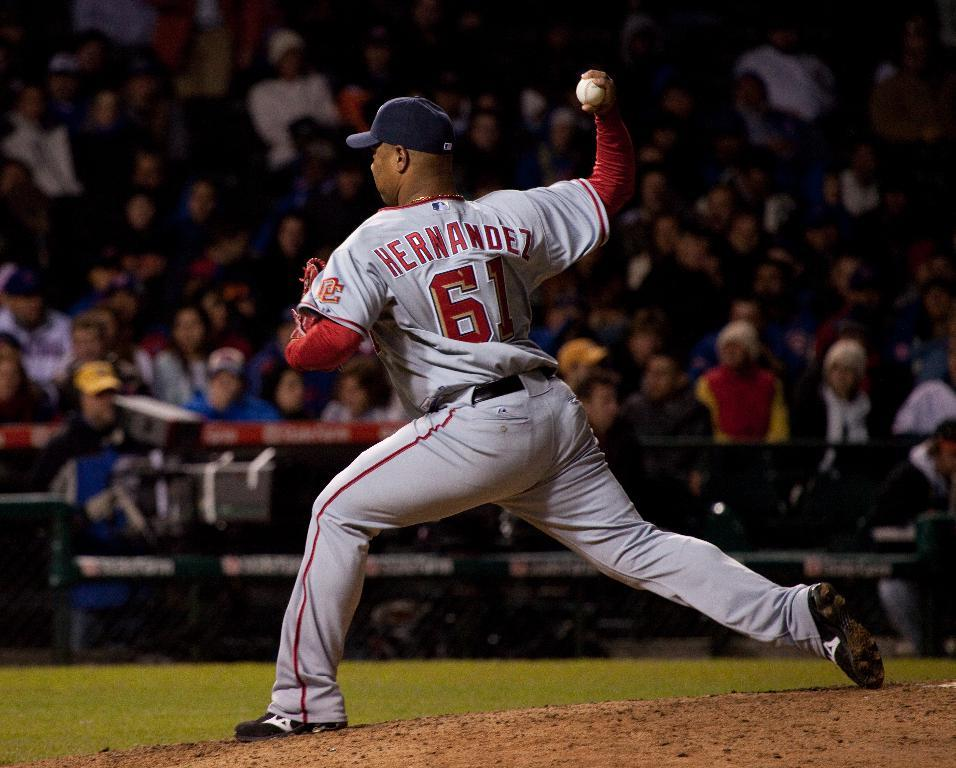<image>
Provide a brief description of the given image. A baseball player named Hernandez is throwing a pitch. 